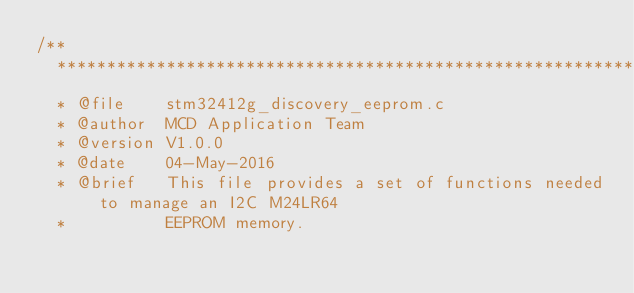<code> <loc_0><loc_0><loc_500><loc_500><_C_>/**
  ******************************************************************************
  * @file    stm32412g_discovery_eeprom.c
  * @author  MCD Application Team
  * @version V1.0.0
  * @date    04-May-2016
  * @brief   This file provides a set of functions needed to manage an I2C M24LR64 
  *          EEPROM memory.</code> 